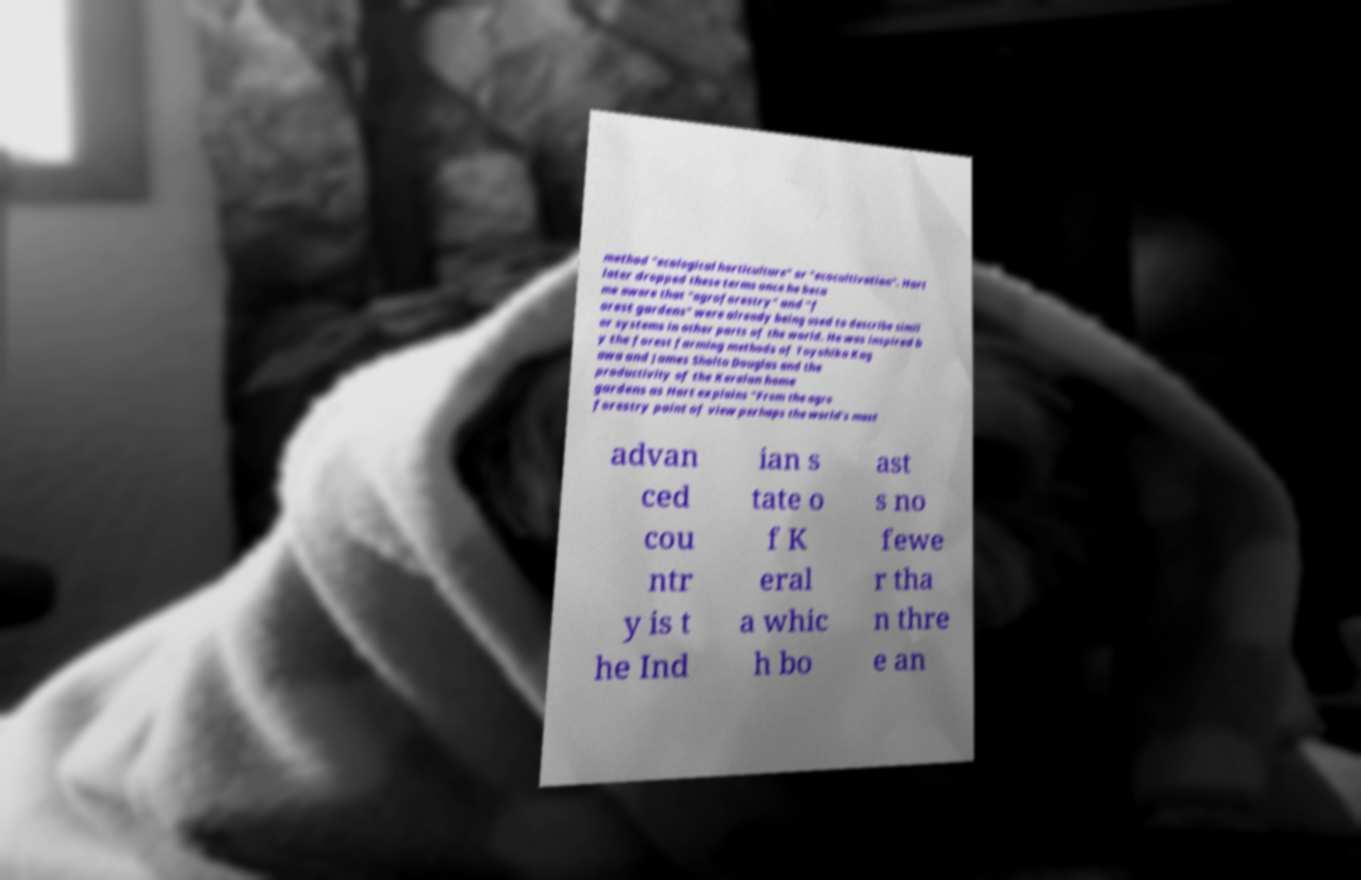What messages or text are displayed in this image? I need them in a readable, typed format. method "ecological horticulture" or "ecocultivation". Hart later dropped these terms once he beca me aware that "agroforestry" and "f orest gardens" were already being used to describe simil ar systems in other parts of the world. He was inspired b y the forest farming methods of Toyohiko Kag awa and James Sholto Douglas and the productivity of the Keralan home gardens as Hart explains "From the agro forestry point of view perhaps the world's most advan ced cou ntr y is t he Ind ian s tate o f K eral a whic h bo ast s no fewe r tha n thre e an 